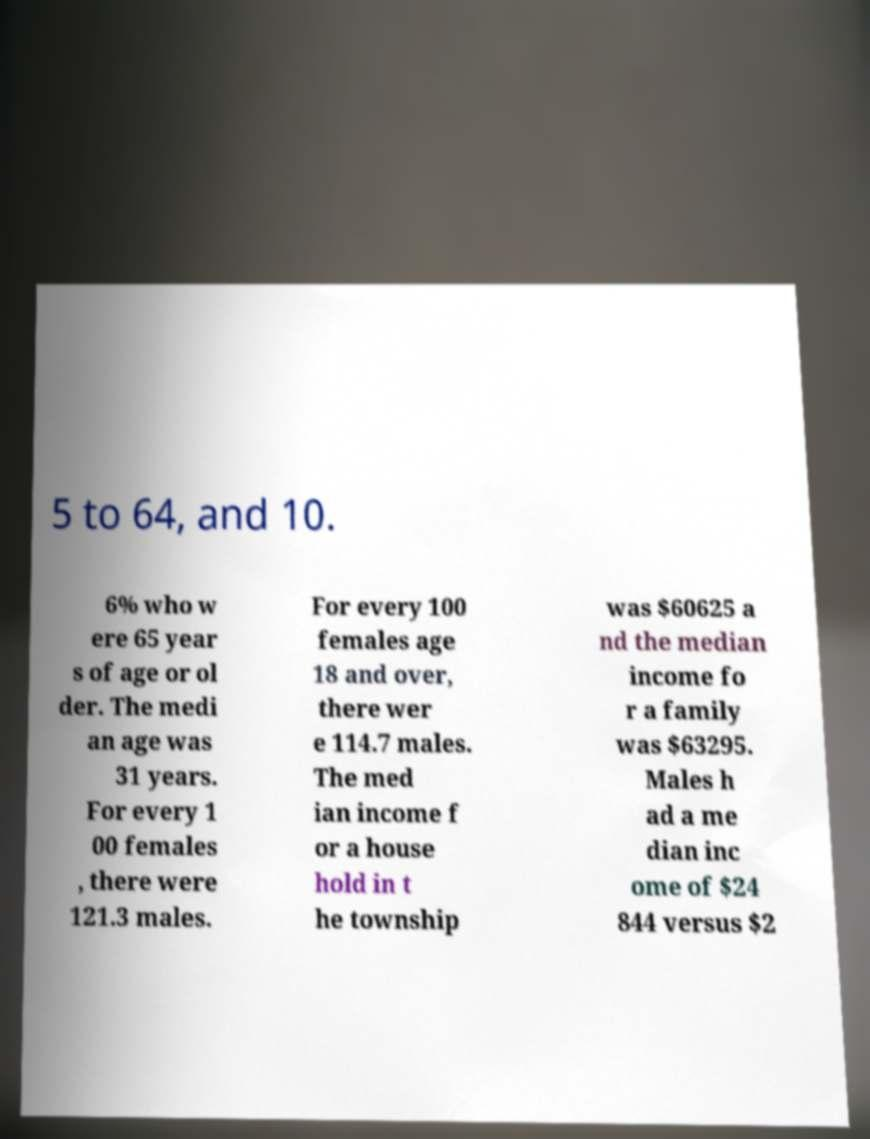Could you extract and type out the text from this image? 5 to 64, and 10. 6% who w ere 65 year s of age or ol der. The medi an age was 31 years. For every 1 00 females , there were 121.3 males. For every 100 females age 18 and over, there wer e 114.7 males. The med ian income f or a house hold in t he township was $60625 a nd the median income fo r a family was $63295. Males h ad a me dian inc ome of $24 844 versus $2 